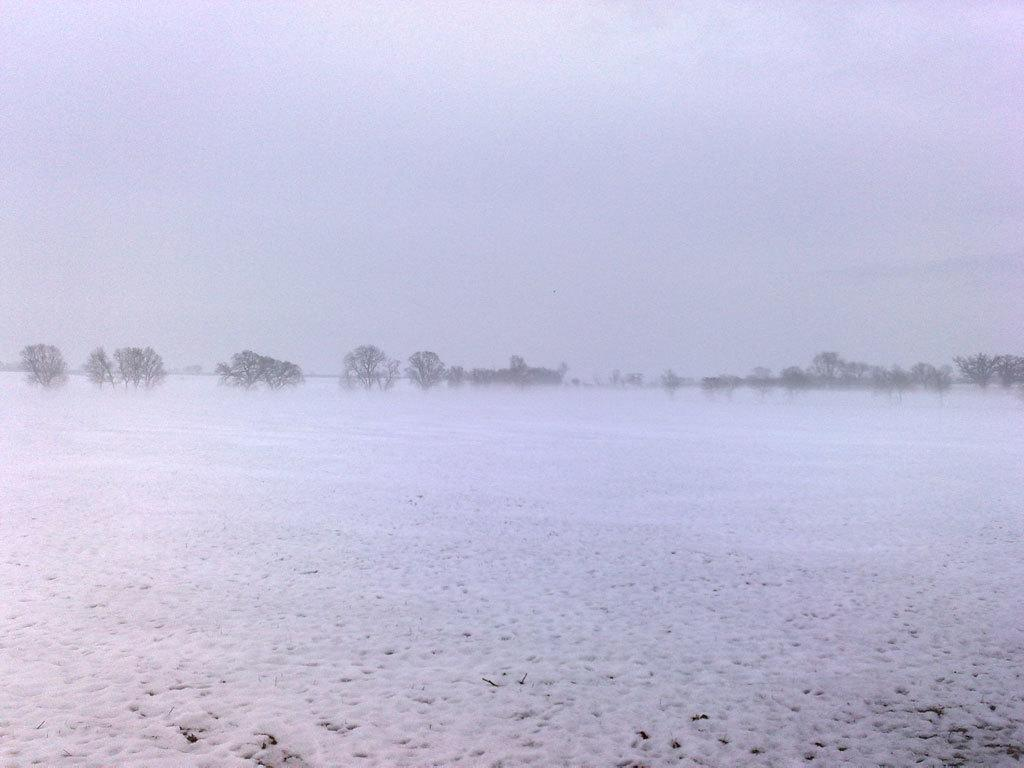What type of weather condition is depicted in the image? There is snow in the image, indicating a winter scene. What natural elements can be seen in the image? There are trees in the image. What is visible in the background of the image? The sky is visible in the background of the image. How much profit did your uncle make from the yard sale in the image? There is no reference to an uncle, yard sale, or profit in the image, so it is not possible to answer that question. 